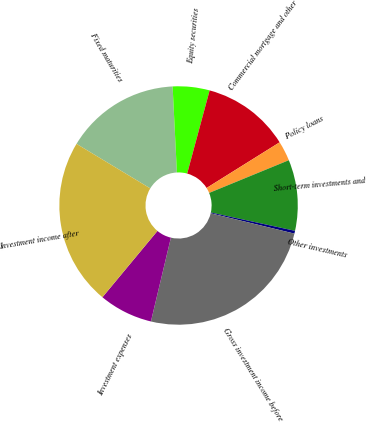<chart> <loc_0><loc_0><loc_500><loc_500><pie_chart><fcel>Fixed maturities<fcel>Equity securities<fcel>Commercial mortgage and other<fcel>Policy loans<fcel>Short-term investments and<fcel>Other investments<fcel>Gross investment income before<fcel>Investment expenses<fcel>Investment income after<nl><fcel>15.56%<fcel>4.99%<fcel>11.91%<fcel>2.69%<fcel>9.61%<fcel>0.38%<fcel>24.93%<fcel>7.3%<fcel>22.62%<nl></chart> 